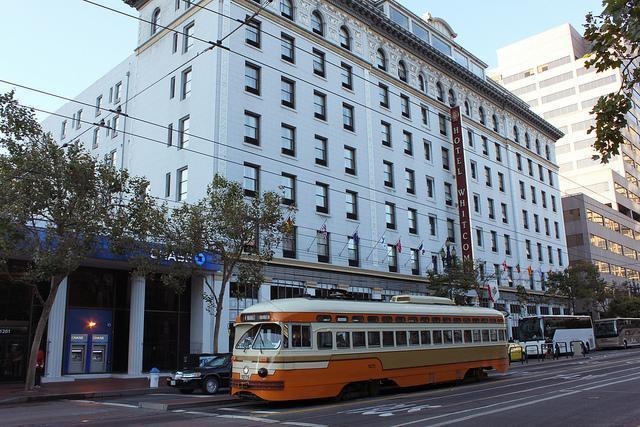How many buses are there?
Give a very brief answer. 3. 